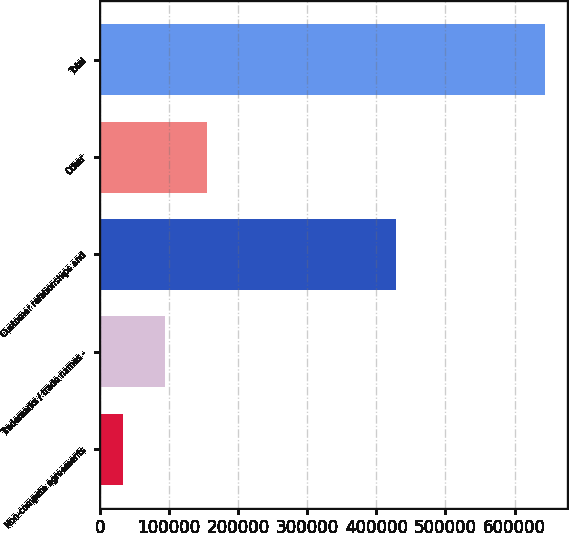<chart> <loc_0><loc_0><loc_500><loc_500><bar_chart><fcel>Non-compete agreements<fcel>Trademarks / trade names -<fcel>Customer relationships and<fcel>Other<fcel>Total<nl><fcel>33454<fcel>94482.2<fcel>428032<fcel>155510<fcel>643736<nl></chart> 